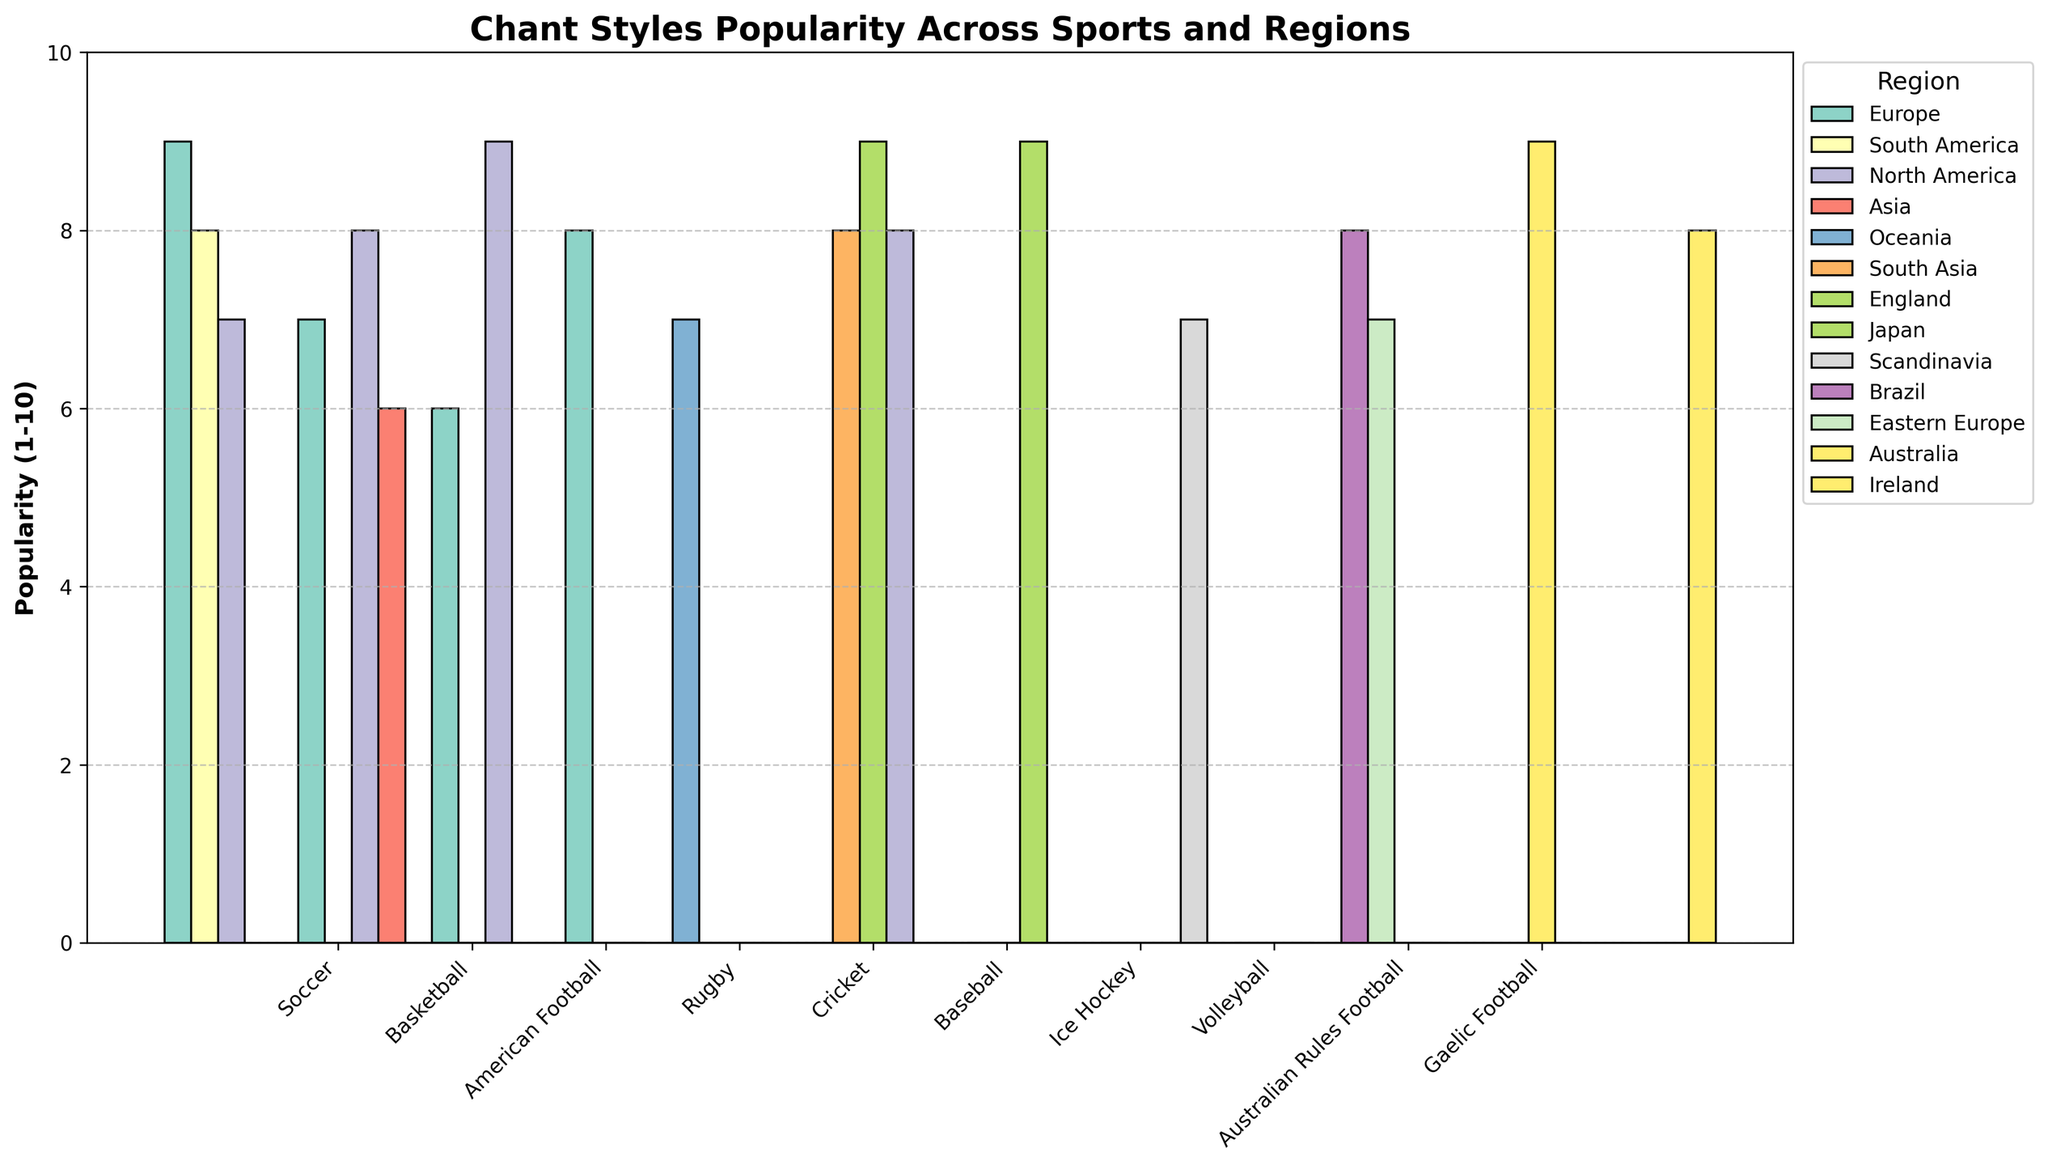Which sport has the highest chant style popularity in Europe? First, look for the bars representing Europe. Next, identify the bar with the greatest height among those for Europe, which corresponds to Soccer.
Answer: Soccer What is the total popularity of all chant styles in North America? Identify the bars representing North America in the chart. Sum the popularity values for Soccer, Basketball, American Football, Baseball, and Ice Hockey: 7 + 8 + 9 + 8 + 8 = 40.
Answer: 40 Which region has the most varied chant styles across different sports? Examine the legend to spot the distinct colors for different regions. Count the number of unique bars in each color. Europe has the most varied styles, represented in Soccer, Basketball, American Football, Rugby, and Cricket.
Answer: Europe Compare the popularity of rhythmic drumming chant style in South America and orchestrated cheering in Japan. Identify the bars for Rhythmic Drumming in South America and Orchestrated Cheering in Japan. The heights of the bars indicate the popularity values: South America (8) and Japan (9). Therefore, Orchestrated Cheering in Japan is more popular.
Answer: Orchestrated Cheering in Japan What is the average popularity of chant styles in Soccer? Identify the bars for Soccer across all regions and sum their popularity values (9 + 8 + 7). Divide the total by the number of regions (3). The average is (9 + 8 + 7) / 3 = 8.
Answer: 8 Which sport has the lowest chant style popularity in Asia? Locate the bars for Asia and identify the one with the smallest height. Coordinated Clapping in Basketball shows a popularity value of 6, which is the lowest.
Answer: Basketball What’s the difference in popularity between Haka-inspired chant style in Europe and National Anthem Adaption in Oceania for Rugby? Identify the bars for Haka-inspired chant style in Europe and National Anthem Adaption in Oceania. Their popularity values are 8 and 7, respectively. The difference is 8 - 7 = 1.
Answer: 1 How many regions have a chant style popularity of 8 or higher for Ice Hockey? Identify the bars for Ice Hockey in different regions and note their popularity values. North America (8) and Scandinavia (7). Only North America has a value of 8 or higher.
Answer: 1 Which has a higher popularity: Bhangra-style chant in South Asia (Cricket) or Samba-inspired chant in Brazil (Volleyball)? Identify the bars for Bhangra-style chant in South Asia and Samba-inspired chant in Brazil. Their popularity values are 8 and 8, respectively. Thus, they have equal popularity.
Answer: Equal What is the combined popularity of chant styles for Baseball in North America and Japan? Identify the bars for Baseball in North America and Japan. Sum their popularity values: 8 (North America) + 9 (Japan) = 17.
Answer: 17 